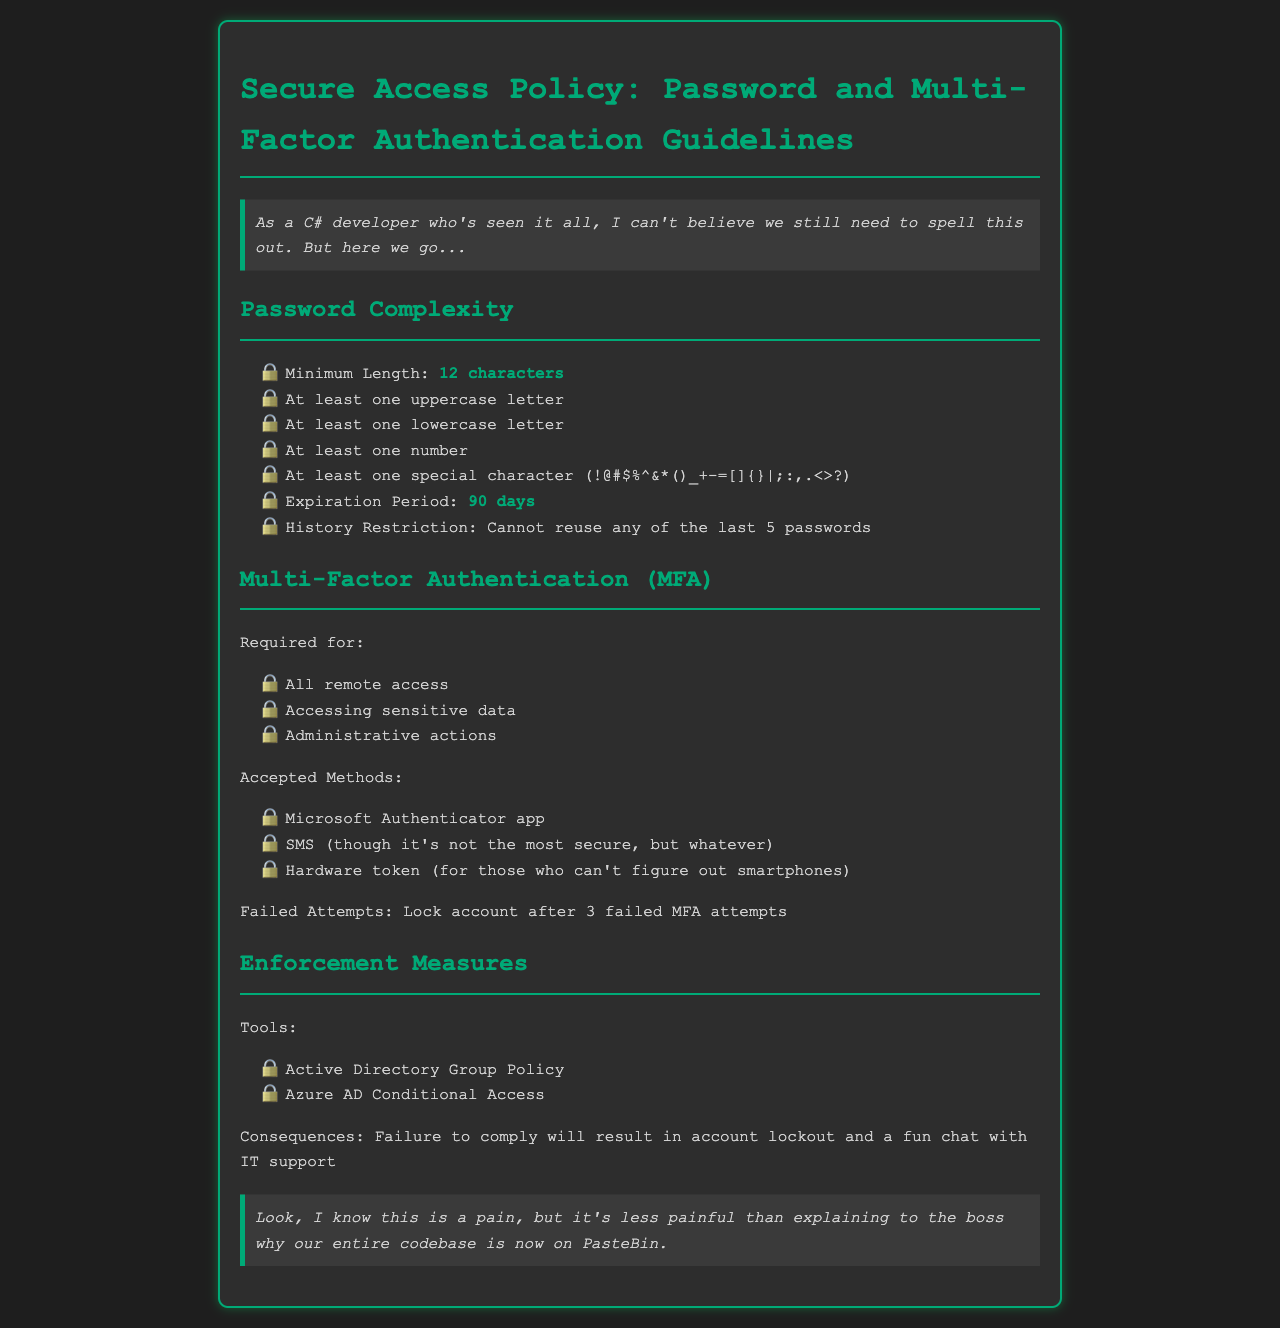What is the minimum password length? The minimum password length is specified in the document as part of the password complexity requirements.
Answer: 12 characters What is the expiration period for passwords? This detail is mentioned under the password complexity section, outlining how often passwords should be changed.
Answer: 90 days How many passwords cannot be reused? The document specifies a rule regarding the history of passwords related to reuse.
Answer: 5 passwords What methods are accepted for Multi-Factor Authentication? The document lists the methods that can be used for MFA, which includes various options.
Answer: Microsoft Authenticator app, SMS, Hardware token How many failed MFA attempts lead to an account lock? The protocol for failed attempts is established in the MFA section of the document.
Answer: 3 failed attempts What will happen if someone fails to comply with the policy? This specifically outlines the consequences of not adhering to the security policy, detailing what enforcement measures will take place.
Answer: Account lockout and a fun chat with IT support For what scenarios is Multi-Factor Authentication required? The document outlines specific situations where MFA is mandated.
Answer: All remote access, Accessing sensitive data, Administrative actions What tools are mentioned for enforcement measures? This part of the document lists the tools that are employed to enforce the security policy.
Answer: Active Directory Group Policy, Azure AD Conditional Access 